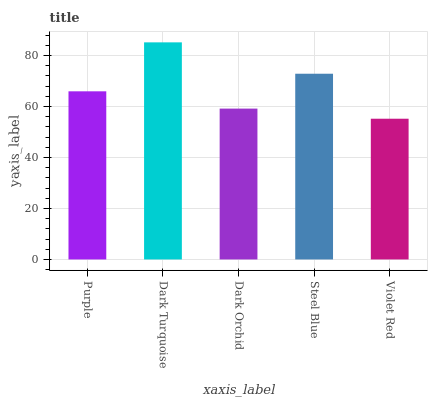Is Dark Orchid the minimum?
Answer yes or no. No. Is Dark Orchid the maximum?
Answer yes or no. No. Is Dark Turquoise greater than Dark Orchid?
Answer yes or no. Yes. Is Dark Orchid less than Dark Turquoise?
Answer yes or no. Yes. Is Dark Orchid greater than Dark Turquoise?
Answer yes or no. No. Is Dark Turquoise less than Dark Orchid?
Answer yes or no. No. Is Purple the high median?
Answer yes or no. Yes. Is Purple the low median?
Answer yes or no. Yes. Is Violet Red the high median?
Answer yes or no. No. Is Violet Red the low median?
Answer yes or no. No. 